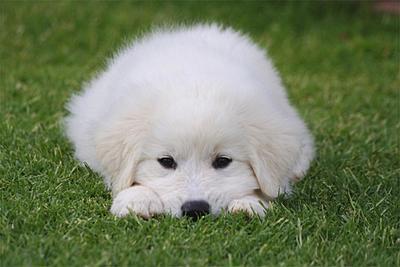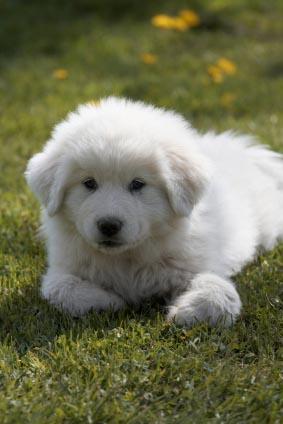The first image is the image on the left, the second image is the image on the right. For the images shown, is this caption "Left image shows fluffy dog standing on green grass." true? Answer yes or no. No. The first image is the image on the left, the second image is the image on the right. For the images displayed, is the sentence "One of the dogs is standing in a side profile pose." factually correct? Answer yes or no. No. The first image is the image on the left, the second image is the image on the right. For the images shown, is this caption "In at least one of the images, a white dog is laying down in grass" true? Answer yes or no. Yes. The first image is the image on the left, the second image is the image on the right. Assess this claim about the two images: "The right image contains one white dog that is laying down in the grass.". Correct or not? Answer yes or no. Yes. 